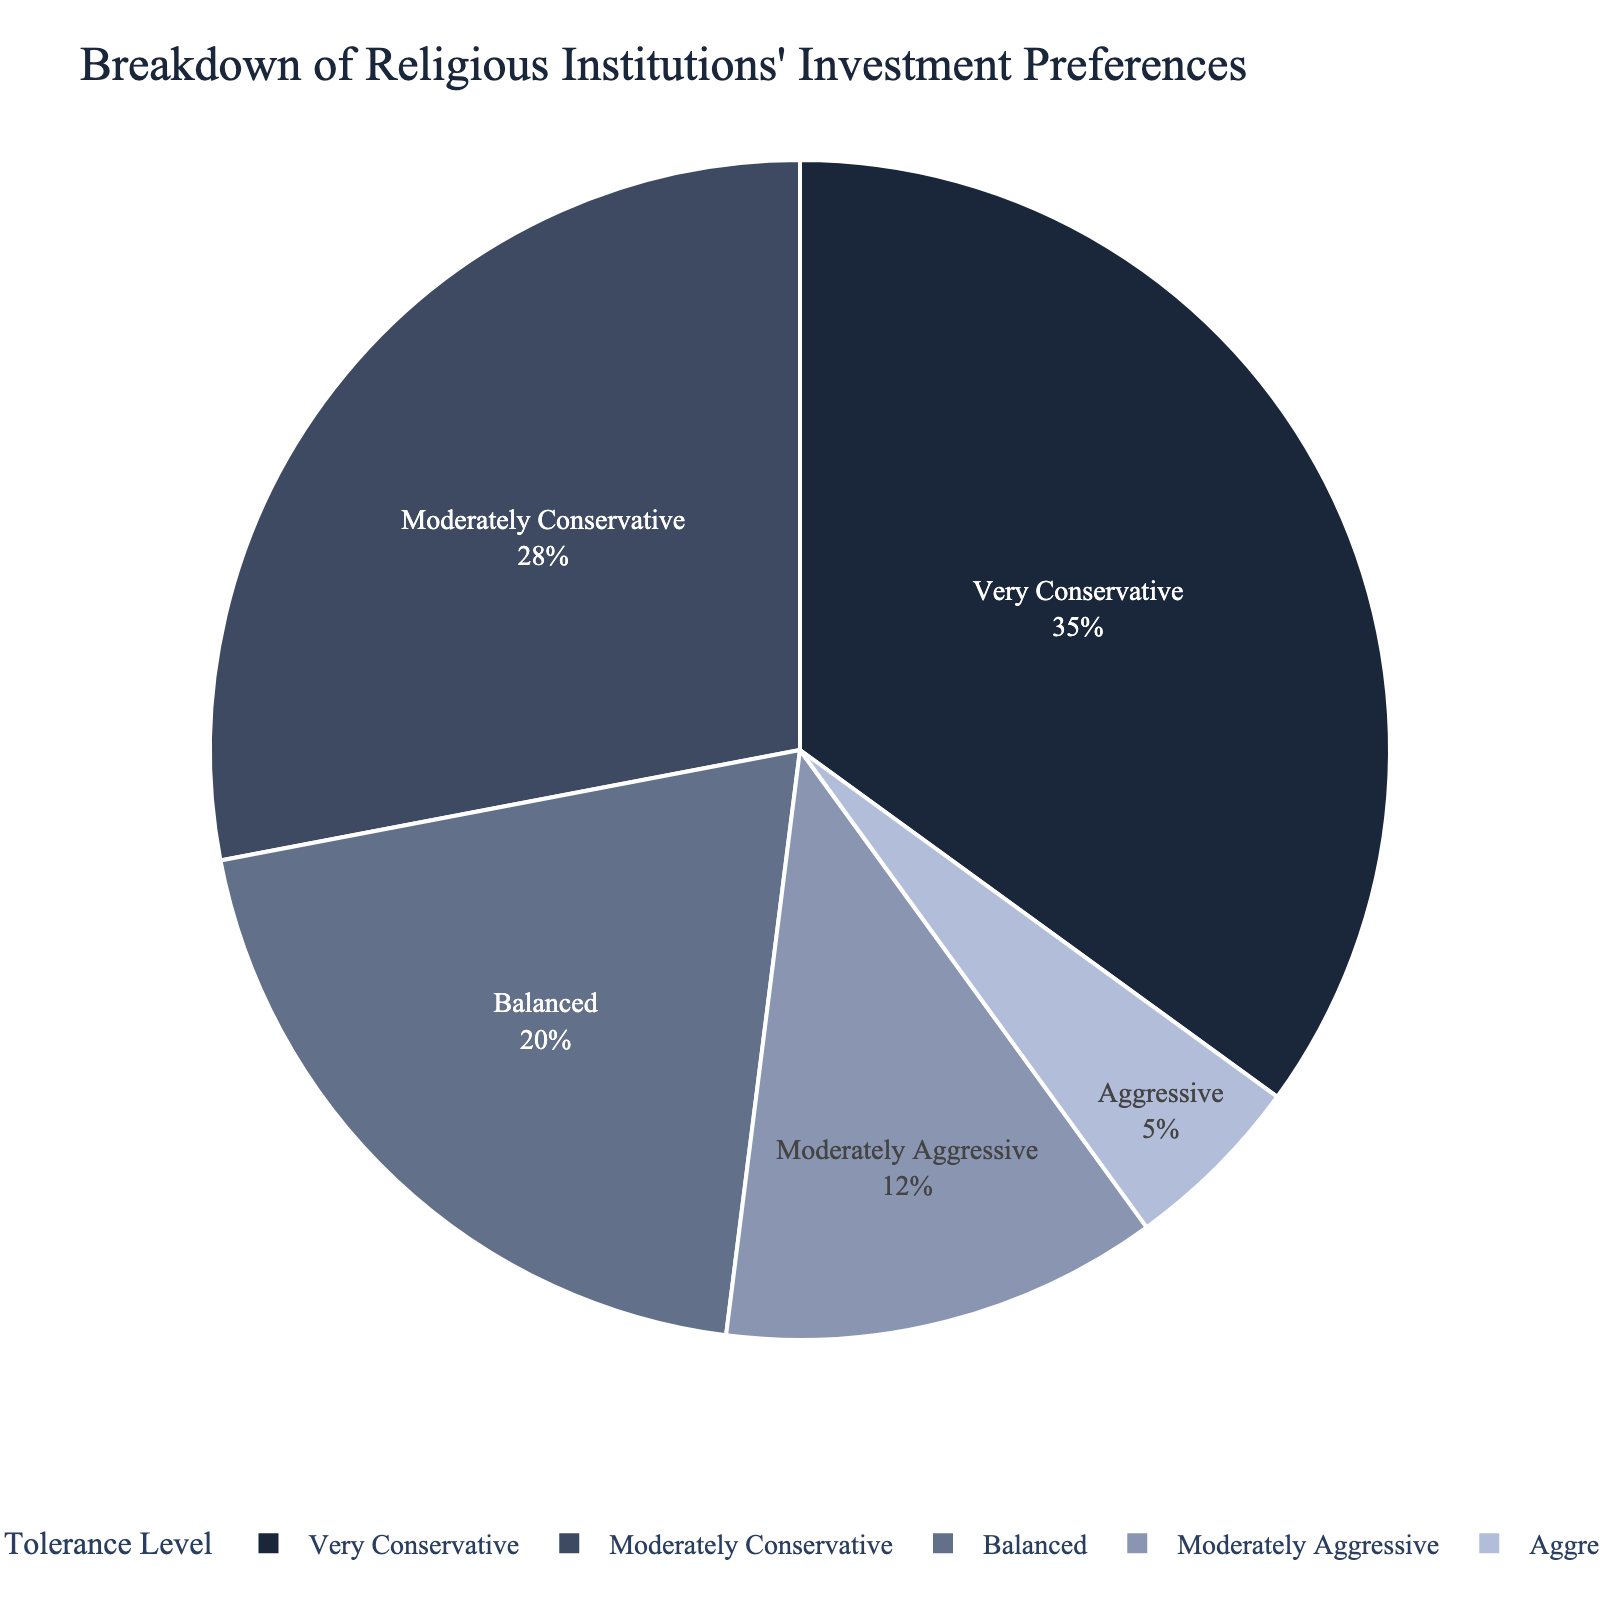What is the most common risk tolerance level among religious institutions? The most common risk tolerance level is indicated by the largest portion of the pie chart. From the chart, the 'Very Conservative' segment is the largest.
Answer: Very Conservative Which risk tolerance level has a smaller percentage, Moderately Conservative or Balanced? To determine which has a smaller percentage, compare the sizes of the Moderately Conservative (28%) and Balanced (20%) segments. Balanced is smaller.
Answer: Balanced What is the combined percentage of religious institutions preferring Balanced and Moderately Aggressive investments? Add the percentages of Balanced (20%) and Moderately Aggressive (12%) segments. 20% + 12% = 32%.
Answer: 32% How much more common is a Very Conservative risk tolerance compared to an Aggressive one among religious institutions? Subtract the percentage of Aggressive (5%) from the percentage of Very Conservative (35%). 35% - 5% = 30%.
Answer: 30% What percentage of religious institutions have a Moderate or higher risk tolerance? Sum the percentages of Moderately Conservative (28%), Balanced (20%), Moderately Aggressive (12%), and Aggressive (5%). 28% + 20% + 12% + 5% = 65%.
Answer: 65% Which risk tolerance level has the smallest representation? The smallest portion in the pie chart represents the least common risk tolerance level, which is Aggressive (5%).
Answer: Aggressive Between Moderately Conservative and Moderately Aggressive, which has the larger portion, and by how much? Compare the percentages of Moderately Conservative (28%) and Moderately Aggressive (12%). Subtract the smaller percentage from the larger one. 28% - 12% = 16%.
Answer: Moderately Conservative by 16% How does the percentage of Balanced compare to the combined percentage of Moderately Conservative and Moderately Aggressive? Add the percentages of Moderately Conservative (28%) and Moderately Aggressive (12%) and compare to Balanced. 28% + 12% = 40%, which is greater than 20%.
Answer: Combined is greater by 20% What is the sum of the percentages for all levels except Very Conservative? Subtract the percentage of Very Conservative (35%) from the total (100%). 100% - 35% = 65%.
Answer: 65% Is the percentage of Very Conservative institutions greater than the combined percentage of Balanced and Aggressive institutions? Add the percentages of Balanced (20%) and Aggressive (5%) and compare to Very Conservative. 20% + 5% = 25%, which is less than 35%.
Answer: Yes 